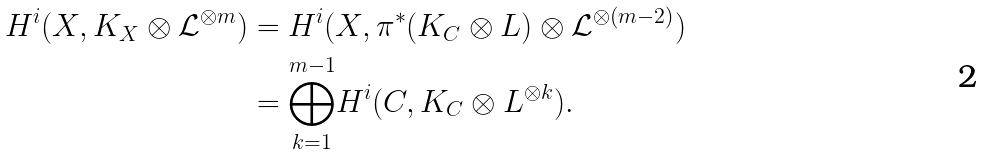Convert formula to latex. <formula><loc_0><loc_0><loc_500><loc_500>H ^ { i } ( X , K _ { X } \otimes \mathcal { L } ^ { \otimes m } ) & = H ^ { i } ( X , \pi ^ { * } ( K _ { C } \otimes L ) \otimes \mathcal { L } ^ { \otimes ( m - 2 ) } ) \\ & = \overset { m - 1 } { \underset { k = 1 } \bigoplus } H ^ { i } ( C , K _ { C } \otimes L ^ { \otimes k } ) .</formula> 